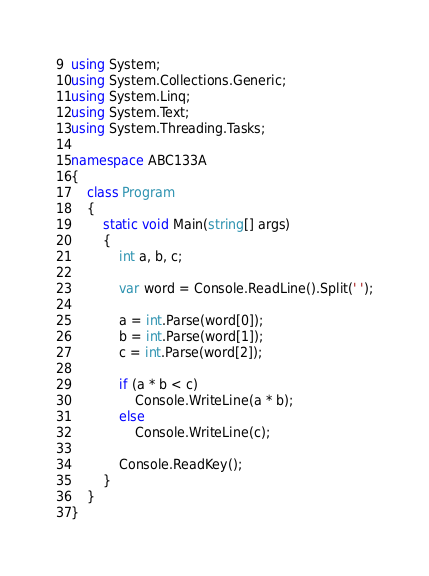<code> <loc_0><loc_0><loc_500><loc_500><_C#_>using System;
using System.Collections.Generic;
using System.Linq;
using System.Text;
using System.Threading.Tasks;

namespace ABC133A
{
    class Program
    {
        static void Main(string[] args)
        {
            int a, b, c;

            var word = Console.ReadLine().Split(' ');

            a = int.Parse(word[0]);
            b = int.Parse(word[1]);
            c = int.Parse(word[2]);

            if (a * b < c)
                Console.WriteLine(a * b);
            else
                Console.WriteLine(c);

            Console.ReadKey();
        }
    }
}
</code> 